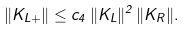<formula> <loc_0><loc_0><loc_500><loc_500>\| K _ { L + } \| \leq c _ { 4 } \, \| K _ { L } \| ^ { 2 } \, \| K _ { R } \| .</formula> 